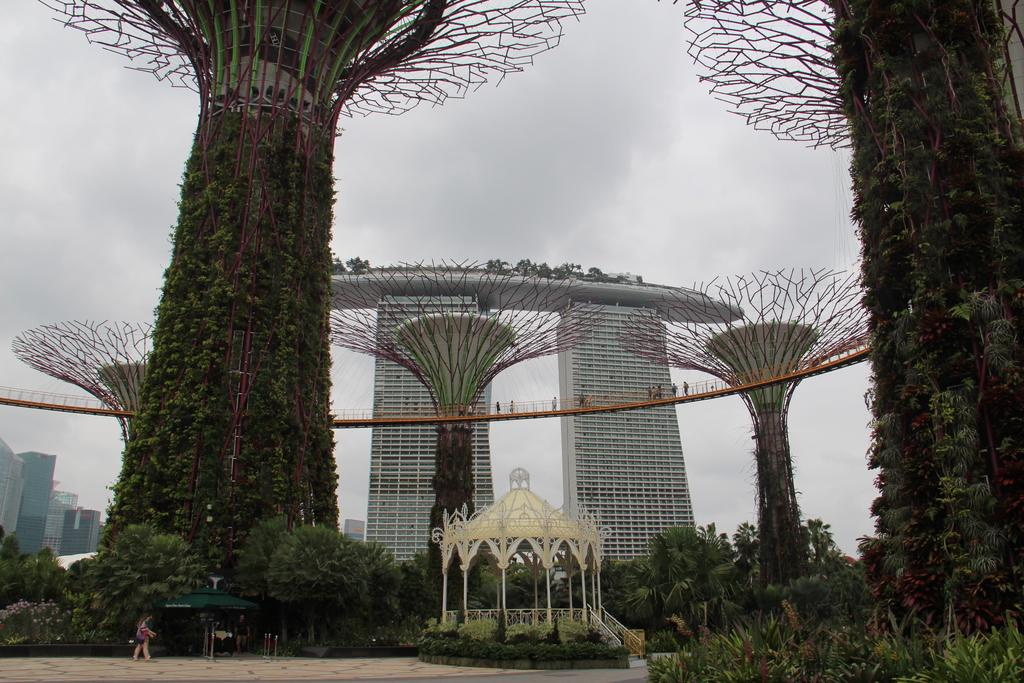What types of vegetation can be seen in the image? There are multiple plants and trees in the image. What structures are visible in the image? There are multiple buildings in the image. What can be seen in the sky in the image? Clouds and the sky are visible in the image. What type of outdoor structures are present at the bottom of the image? There are open sheds at the bottom of the image. How many people are present in the image? Two persons are present in the image. What type of feast is being prepared in the image? There is no feast being prepared in the image; it features multiple plants, plants, trees, buildings, clouds, sky, open sheds, and two persons. 